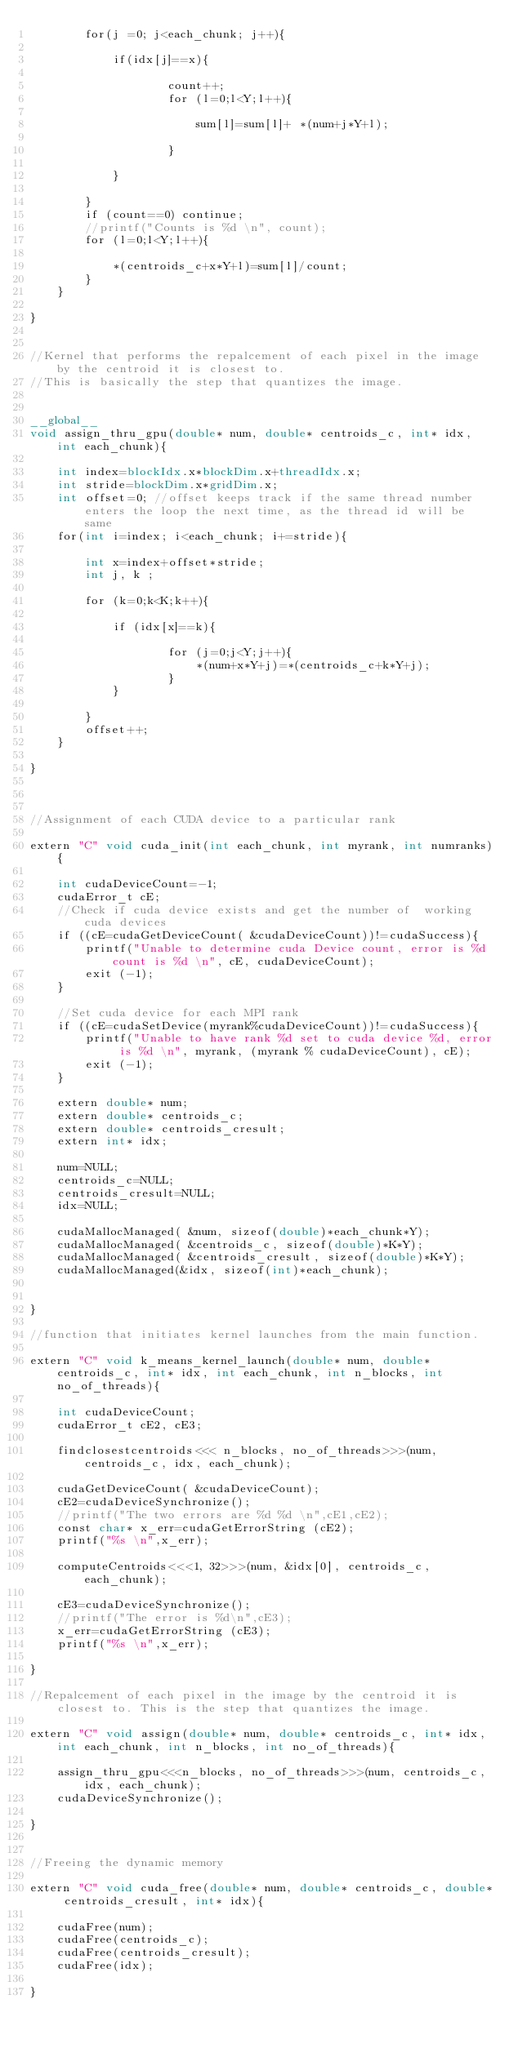Convert code to text. <code><loc_0><loc_0><loc_500><loc_500><_Cuda_>		for(j =0; j<each_chunk; j++){

			if(idx[j]==x){

					count++;
					for (l=0;l<Y;l++){

						sum[l]=sum[l]+ *(num+j*Y+l);
					
					}
			
			}

		}
		if (count==0) continue;
		//printf("Counts is %d \n", count);
		for (l=0;l<Y;l++){

			*(centroids_c+x*Y+l)=sum[l]/count;					
		}
	}

}


//Kernel that performs the repalcement of each pixel in the image by the centroid it is closest to. 
//This is basically the step that quantizes the image.	


__global__
void assign_thru_gpu(double* num, double* centroids_c, int* idx, int each_chunk){
	
	int index=blockIdx.x*blockDim.x+threadIdx.x;
	int stride=blockDim.x*gridDim.x;
	int offset=0; //offset keeps track if the same thread number enters the loop the next time, as the thread id will be same
	for(int i=index; i<each_chunk; i+=stride){
		
		int x=index+offset*stride;
		int j, k ; 

		for (k=0;k<K;k++){

			if (idx[x]==k){

					for (j=0;j<Y;j++){			
						*(num+x*Y+j)=*(centroids_c+k*Y+j);
					}
			}
				
		}
		offset++;
	}

}



//Assignment of each CUDA device to a particular rank

extern "C" void cuda_init(int each_chunk, int myrank, int numranks){

	int cudaDeviceCount=-1;
	cudaError_t cE;
	//Check if cuda device exists and get the number of  working cuda devices
    if ((cE=cudaGetDeviceCount( &cudaDeviceCount))!=cudaSuccess){
	    printf("Unable to determine cuda Device count, error is %d count is %d \n", cE, cudaDeviceCount);
	    exit (-1);
	}
	
	//Set cuda device for each MPI rank 	
	if ((cE=cudaSetDevice(myrank%cudaDeviceCount))!=cudaSuccess){
	    printf("Unable to have rank %d set to cuda device %d, error is %d \n", myrank, (myrank % cudaDeviceCount), cE);
	    exit (-1);
	}

	extern double* num;
	extern double* centroids_c;
	extern double* centroids_cresult;
	extern int* idx;

	num=NULL;
	centroids_c=NULL;
	centroids_cresult=NULL;
	idx=NULL; 

	cudaMallocManaged( &num, sizeof(double)*each_chunk*Y);
    cudaMallocManaged( &centroids_c, sizeof(double)*K*Y);
    cudaMallocManaged( &centroids_cresult, sizeof(double)*K*Y);
	cudaMallocManaged(&idx, sizeof(int)*each_chunk);


}
    
//function that initiates kernel launches from the main function.

extern "C" void k_means_kernel_launch(double* num, double* centroids_c, int* idx, int each_chunk, int n_blocks, int no_of_threads){
	
	int cudaDeviceCount;
	cudaError_t cE2, cE3;

	findclosestcentroids<<< n_blocks, no_of_threads>>>(num, centroids_c, idx, each_chunk);
		
	cudaGetDeviceCount( &cudaDeviceCount);
	cE2=cudaDeviceSynchronize();
	//printf("The two errors are %d %d \n",cE1,cE2);
	const char* x_err=cudaGetErrorString (cE2);
	printf("%s \n",x_err); 

	computeCentroids<<<1, 32>>>(num, &idx[0], centroids_c,each_chunk);

	cE3=cudaDeviceSynchronize();
	//printf("The error is %d\n",cE3);
	x_err=cudaGetErrorString (cE3);
	printf("%s \n",x_err); 

}

//Repalcement of each pixel in the image by the centroid it is closest to. This is the step that quantizes the image.	

extern "C" void assign(double* num, double* centroids_c, int* idx, int each_chunk, int n_blocks, int no_of_threads){
	
	assign_thru_gpu<<<n_blocks, no_of_threads>>>(num, centroids_c, idx, each_chunk);
	cudaDeviceSynchronize();

}


//Freeing the dynamic memory 

extern "C" void cuda_free(double* num, double* centroids_c, double* centroids_cresult, int* idx){
	
	cudaFree(num);
	cudaFree(centroids_c);
	cudaFree(centroids_cresult);
	cudaFree(idx);

}
</code> 